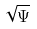<formula> <loc_0><loc_0><loc_500><loc_500>\sqrt { \Psi }</formula> 